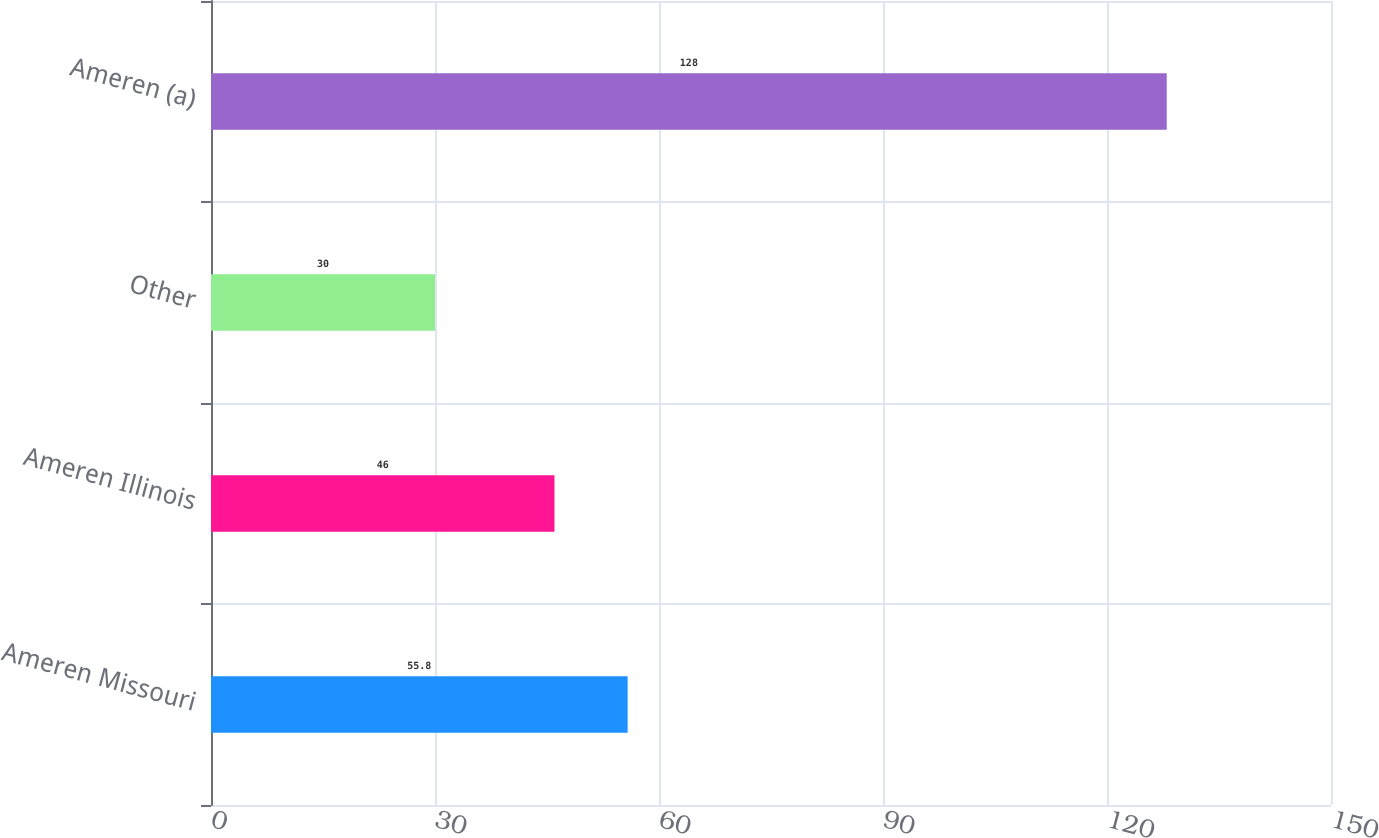Convert chart. <chart><loc_0><loc_0><loc_500><loc_500><bar_chart><fcel>Ameren Missouri<fcel>Ameren Illinois<fcel>Other<fcel>Ameren (a)<nl><fcel>55.8<fcel>46<fcel>30<fcel>128<nl></chart> 